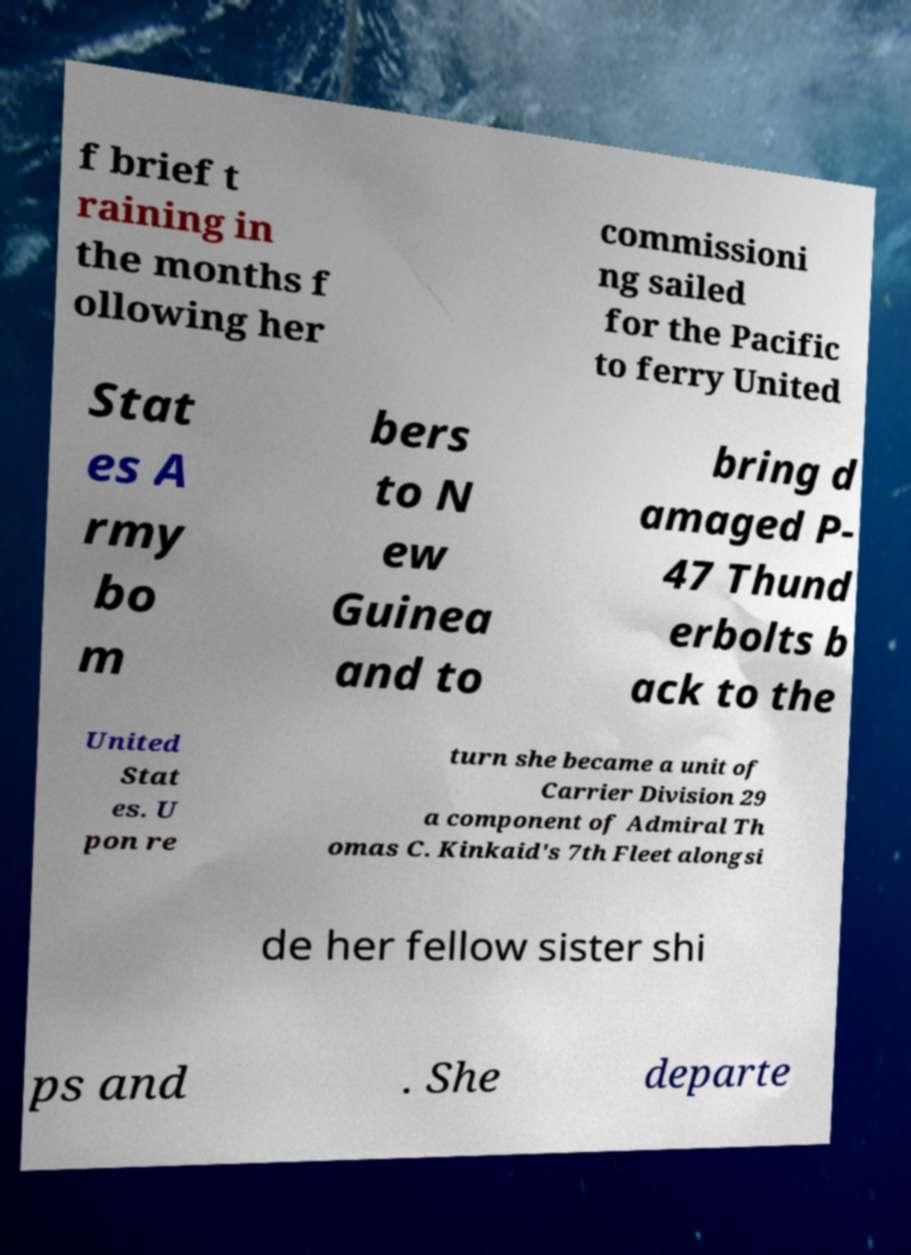What messages or text are displayed in this image? I need them in a readable, typed format. f brief t raining in the months f ollowing her commissioni ng sailed for the Pacific to ferry United Stat es A rmy bo m bers to N ew Guinea and to bring d amaged P- 47 Thund erbolts b ack to the United Stat es. U pon re turn she became a unit of Carrier Division 29 a component of Admiral Th omas C. Kinkaid's 7th Fleet alongsi de her fellow sister shi ps and . She departe 